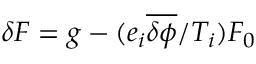Convert formula to latex. <formula><loc_0><loc_0><loc_500><loc_500>\delta F = g - ( e _ { i } \overline { \delta \phi } / T _ { i } ) F _ { 0 }</formula> 